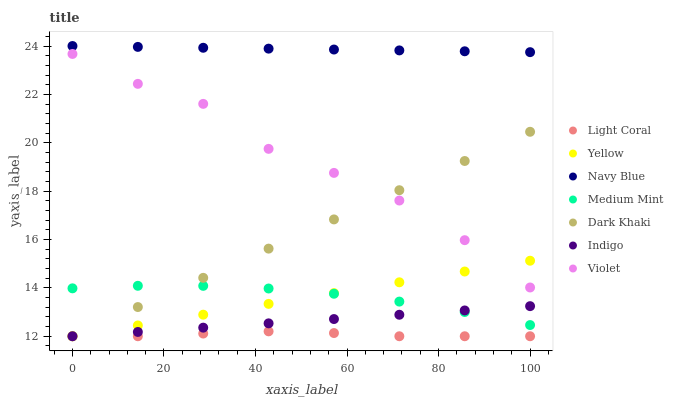Does Light Coral have the minimum area under the curve?
Answer yes or no. Yes. Does Navy Blue have the maximum area under the curve?
Answer yes or no. Yes. Does Dark Khaki have the minimum area under the curve?
Answer yes or no. No. Does Dark Khaki have the maximum area under the curve?
Answer yes or no. No. Is Indigo the smoothest?
Answer yes or no. Yes. Is Violet the roughest?
Answer yes or no. Yes. Is Dark Khaki the smoothest?
Answer yes or no. No. Is Dark Khaki the roughest?
Answer yes or no. No. Does Dark Khaki have the lowest value?
Answer yes or no. Yes. Does Navy Blue have the lowest value?
Answer yes or no. No. Does Navy Blue have the highest value?
Answer yes or no. Yes. Does Dark Khaki have the highest value?
Answer yes or no. No. Is Light Coral less than Violet?
Answer yes or no. Yes. Is Navy Blue greater than Light Coral?
Answer yes or no. Yes. Does Dark Khaki intersect Medium Mint?
Answer yes or no. Yes. Is Dark Khaki less than Medium Mint?
Answer yes or no. No. Is Dark Khaki greater than Medium Mint?
Answer yes or no. No. Does Light Coral intersect Violet?
Answer yes or no. No. 